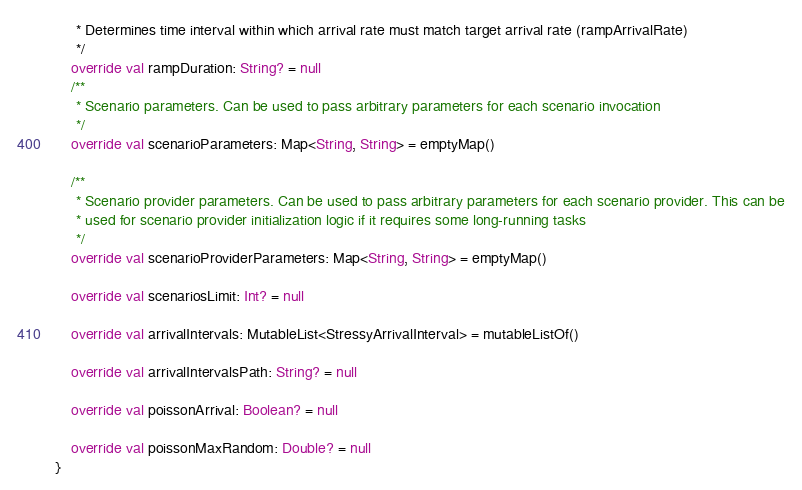Convert code to text. <code><loc_0><loc_0><loc_500><loc_500><_Kotlin_>     * Determines time interval within which arrival rate must match target arrival rate (rampArrivalRate)
     */
    override val rampDuration: String? = null
    /**
     * Scenario parameters. Can be used to pass arbitrary parameters for each scenario invocation
     */
    override val scenarioParameters: Map<String, String> = emptyMap()

    /**
     * Scenario provider parameters. Can be used to pass arbitrary parameters for each scenario provider. This can be
     * used for scenario provider initialization logic if it requires some long-running tasks
     */
    override val scenarioProviderParameters: Map<String, String> = emptyMap()

    override val scenariosLimit: Int? = null

    override val arrivalIntervals: MutableList<StressyArrivalInterval> = mutableListOf()

    override val arrivalIntervalsPath: String? = null

    override val poissonArrival: Boolean? = null

    override val poissonMaxRandom: Double? = null
}
</code> 